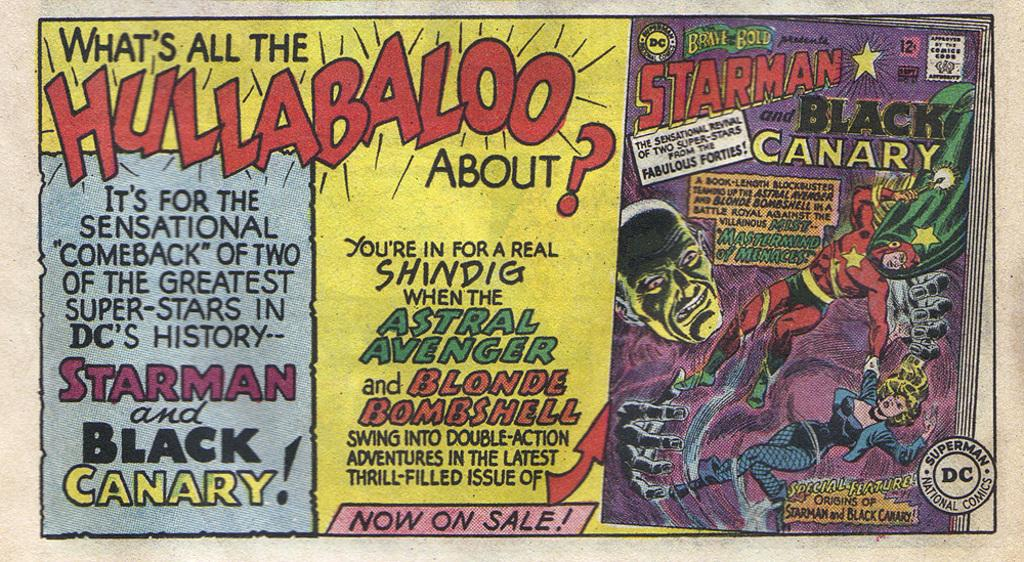<image>
Summarize the visual content of the image. An advertisement says that Starman and Black Canary are making a comeback. 